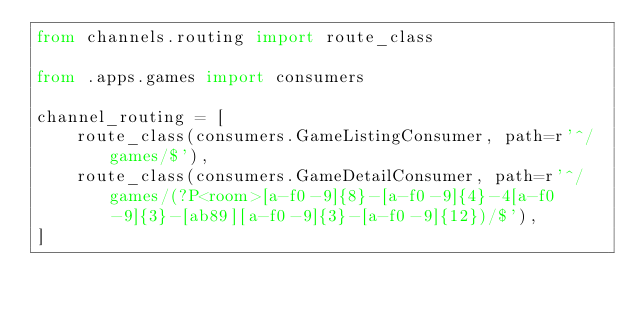Convert code to text. <code><loc_0><loc_0><loc_500><loc_500><_Python_>from channels.routing import route_class

from .apps.games import consumers

channel_routing = [
    route_class(consumers.GameListingConsumer, path=r'^/games/$'),
    route_class(consumers.GameDetailConsumer, path=r'^/games/(?P<room>[a-f0-9]{8}-[a-f0-9]{4}-4[a-f0-9]{3}-[ab89][a-f0-9]{3}-[a-f0-9]{12})/$'),
]
</code> 